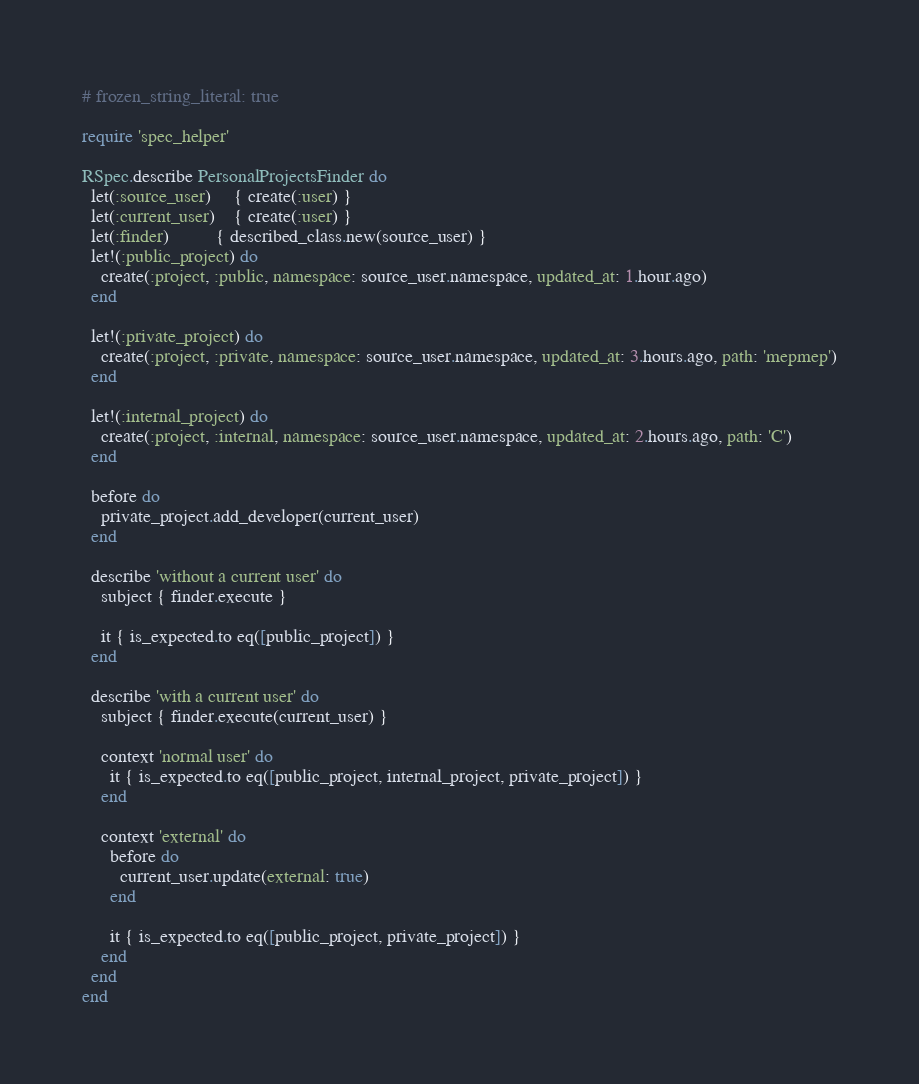<code> <loc_0><loc_0><loc_500><loc_500><_Ruby_># frozen_string_literal: true

require 'spec_helper'

RSpec.describe PersonalProjectsFinder do
  let(:source_user)     { create(:user) }
  let(:current_user)    { create(:user) }
  let(:finder)          { described_class.new(source_user) }
  let!(:public_project) do
    create(:project, :public, namespace: source_user.namespace, updated_at: 1.hour.ago)
  end

  let!(:private_project) do
    create(:project, :private, namespace: source_user.namespace, updated_at: 3.hours.ago, path: 'mepmep')
  end

  let!(:internal_project) do
    create(:project, :internal, namespace: source_user.namespace, updated_at: 2.hours.ago, path: 'C')
  end

  before do
    private_project.add_developer(current_user)
  end

  describe 'without a current user' do
    subject { finder.execute }

    it { is_expected.to eq([public_project]) }
  end

  describe 'with a current user' do
    subject { finder.execute(current_user) }

    context 'normal user' do
      it { is_expected.to eq([public_project, internal_project, private_project]) }
    end

    context 'external' do
      before do
        current_user.update(external: true)
      end

      it { is_expected.to eq([public_project, private_project]) }
    end
  end
end
</code> 